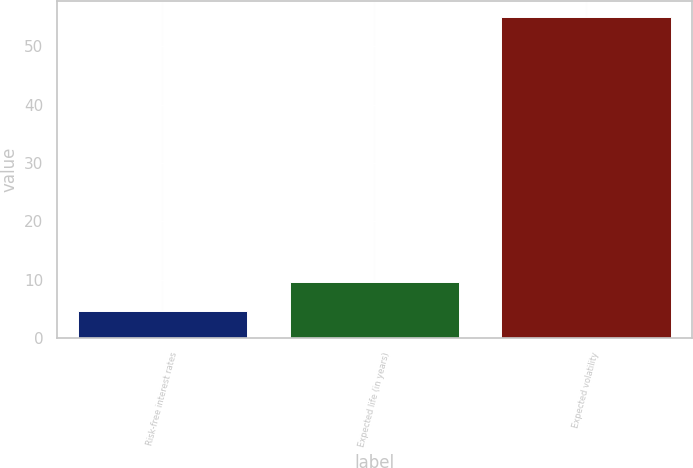Convert chart to OTSL. <chart><loc_0><loc_0><loc_500><loc_500><bar_chart><fcel>Risk-free interest rates<fcel>Expected life (in years)<fcel>Expected volatility<nl><fcel>4.6<fcel>9.64<fcel>55<nl></chart> 